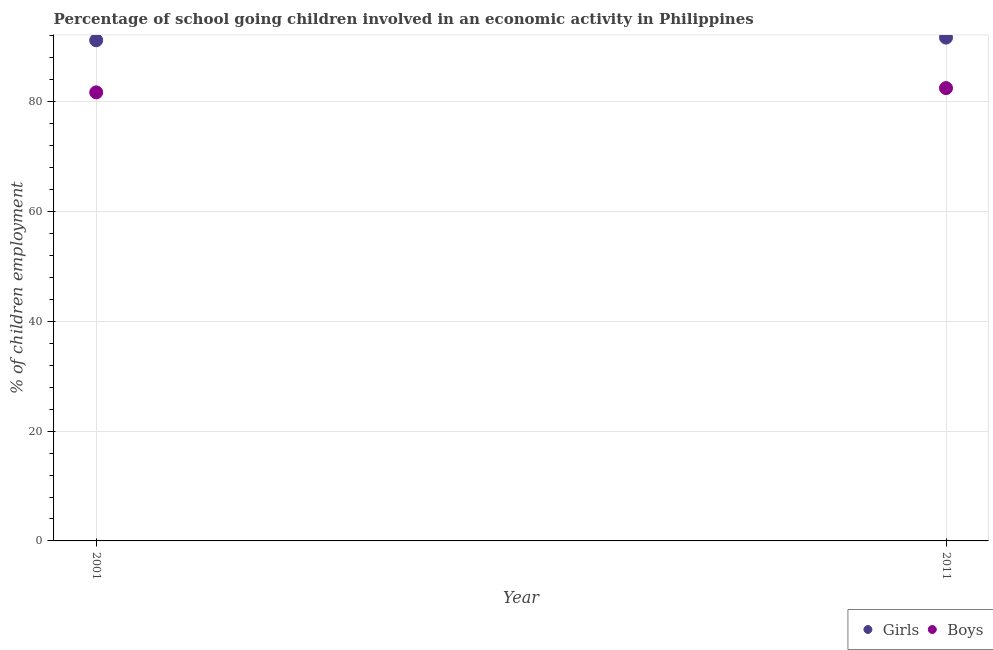What is the percentage of school going boys in 2011?
Make the answer very short. 82.5. Across all years, what is the maximum percentage of school going girls?
Provide a short and direct response. 91.7. Across all years, what is the minimum percentage of school going boys?
Give a very brief answer. 81.73. In which year was the percentage of school going boys maximum?
Offer a very short reply. 2011. In which year was the percentage of school going boys minimum?
Give a very brief answer. 2001. What is the total percentage of school going boys in the graph?
Your answer should be compact. 164.23. What is the difference between the percentage of school going boys in 2001 and that in 2011?
Offer a very short reply. -0.77. What is the difference between the percentage of school going girls in 2011 and the percentage of school going boys in 2001?
Ensure brevity in your answer.  9.97. What is the average percentage of school going boys per year?
Keep it short and to the point. 82.11. In the year 2001, what is the difference between the percentage of school going girls and percentage of school going boys?
Your answer should be very brief. 9.49. In how many years, is the percentage of school going girls greater than 64 %?
Provide a succinct answer. 2. What is the ratio of the percentage of school going girls in 2001 to that in 2011?
Make the answer very short. 0.99. In how many years, is the percentage of school going girls greater than the average percentage of school going girls taken over all years?
Give a very brief answer. 1. Does the percentage of school going girls monotonically increase over the years?
Give a very brief answer. Yes. How many dotlines are there?
Your answer should be very brief. 2. How many years are there in the graph?
Give a very brief answer. 2. Where does the legend appear in the graph?
Make the answer very short. Bottom right. How many legend labels are there?
Make the answer very short. 2. How are the legend labels stacked?
Offer a very short reply. Horizontal. What is the title of the graph?
Your answer should be compact. Percentage of school going children involved in an economic activity in Philippines. Does "Import" appear as one of the legend labels in the graph?
Provide a succinct answer. No. What is the label or title of the X-axis?
Offer a terse response. Year. What is the label or title of the Y-axis?
Offer a very short reply. % of children employment. What is the % of children employment of Girls in 2001?
Your response must be concise. 91.21. What is the % of children employment of Boys in 2001?
Provide a succinct answer. 81.73. What is the % of children employment in Girls in 2011?
Provide a short and direct response. 91.7. What is the % of children employment of Boys in 2011?
Give a very brief answer. 82.5. Across all years, what is the maximum % of children employment in Girls?
Ensure brevity in your answer.  91.7. Across all years, what is the maximum % of children employment of Boys?
Provide a short and direct response. 82.5. Across all years, what is the minimum % of children employment in Girls?
Offer a very short reply. 91.21. Across all years, what is the minimum % of children employment in Boys?
Make the answer very short. 81.73. What is the total % of children employment in Girls in the graph?
Offer a very short reply. 182.91. What is the total % of children employment of Boys in the graph?
Provide a short and direct response. 164.23. What is the difference between the % of children employment in Girls in 2001 and that in 2011?
Give a very brief answer. -0.49. What is the difference between the % of children employment of Boys in 2001 and that in 2011?
Offer a very short reply. -0.77. What is the difference between the % of children employment of Girls in 2001 and the % of children employment of Boys in 2011?
Your response must be concise. 8.71. What is the average % of children employment in Girls per year?
Keep it short and to the point. 91.46. What is the average % of children employment of Boys per year?
Keep it short and to the point. 82.11. In the year 2001, what is the difference between the % of children employment in Girls and % of children employment in Boys?
Offer a terse response. 9.49. In the year 2011, what is the difference between the % of children employment in Girls and % of children employment in Boys?
Make the answer very short. 9.2. What is the ratio of the % of children employment of Boys in 2001 to that in 2011?
Offer a very short reply. 0.99. What is the difference between the highest and the second highest % of children employment of Girls?
Keep it short and to the point. 0.49. What is the difference between the highest and the second highest % of children employment in Boys?
Provide a short and direct response. 0.77. What is the difference between the highest and the lowest % of children employment of Girls?
Provide a short and direct response. 0.49. What is the difference between the highest and the lowest % of children employment in Boys?
Provide a succinct answer. 0.77. 